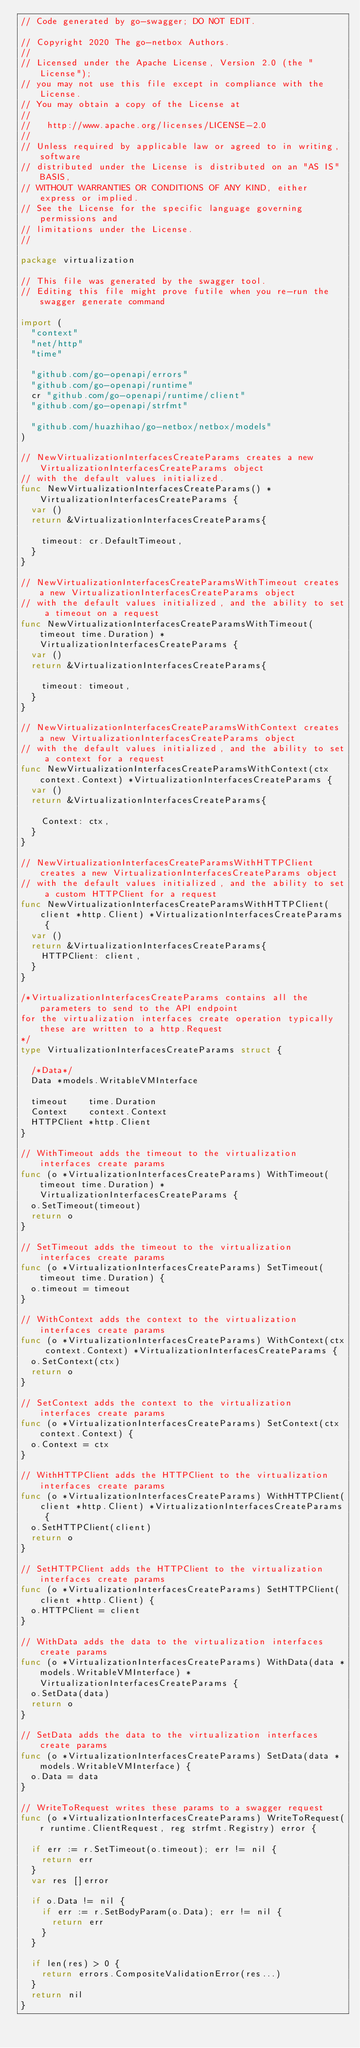Convert code to text. <code><loc_0><loc_0><loc_500><loc_500><_Go_>// Code generated by go-swagger; DO NOT EDIT.

// Copyright 2020 The go-netbox Authors.
//
// Licensed under the Apache License, Version 2.0 (the "License");
// you may not use this file except in compliance with the License.
// You may obtain a copy of the License at
//
//   http://www.apache.org/licenses/LICENSE-2.0
//
// Unless required by applicable law or agreed to in writing, software
// distributed under the License is distributed on an "AS IS" BASIS,
// WITHOUT WARRANTIES OR CONDITIONS OF ANY KIND, either express or implied.
// See the License for the specific language governing permissions and
// limitations under the License.
//

package virtualization

// This file was generated by the swagger tool.
// Editing this file might prove futile when you re-run the swagger generate command

import (
	"context"
	"net/http"
	"time"

	"github.com/go-openapi/errors"
	"github.com/go-openapi/runtime"
	cr "github.com/go-openapi/runtime/client"
	"github.com/go-openapi/strfmt"

	"github.com/huazhihao/go-netbox/netbox/models"
)

// NewVirtualizationInterfacesCreateParams creates a new VirtualizationInterfacesCreateParams object
// with the default values initialized.
func NewVirtualizationInterfacesCreateParams() *VirtualizationInterfacesCreateParams {
	var ()
	return &VirtualizationInterfacesCreateParams{

		timeout: cr.DefaultTimeout,
	}
}

// NewVirtualizationInterfacesCreateParamsWithTimeout creates a new VirtualizationInterfacesCreateParams object
// with the default values initialized, and the ability to set a timeout on a request
func NewVirtualizationInterfacesCreateParamsWithTimeout(timeout time.Duration) *VirtualizationInterfacesCreateParams {
	var ()
	return &VirtualizationInterfacesCreateParams{

		timeout: timeout,
	}
}

// NewVirtualizationInterfacesCreateParamsWithContext creates a new VirtualizationInterfacesCreateParams object
// with the default values initialized, and the ability to set a context for a request
func NewVirtualizationInterfacesCreateParamsWithContext(ctx context.Context) *VirtualizationInterfacesCreateParams {
	var ()
	return &VirtualizationInterfacesCreateParams{

		Context: ctx,
	}
}

// NewVirtualizationInterfacesCreateParamsWithHTTPClient creates a new VirtualizationInterfacesCreateParams object
// with the default values initialized, and the ability to set a custom HTTPClient for a request
func NewVirtualizationInterfacesCreateParamsWithHTTPClient(client *http.Client) *VirtualizationInterfacesCreateParams {
	var ()
	return &VirtualizationInterfacesCreateParams{
		HTTPClient: client,
	}
}

/*VirtualizationInterfacesCreateParams contains all the parameters to send to the API endpoint
for the virtualization interfaces create operation typically these are written to a http.Request
*/
type VirtualizationInterfacesCreateParams struct {

	/*Data*/
	Data *models.WritableVMInterface

	timeout    time.Duration
	Context    context.Context
	HTTPClient *http.Client
}

// WithTimeout adds the timeout to the virtualization interfaces create params
func (o *VirtualizationInterfacesCreateParams) WithTimeout(timeout time.Duration) *VirtualizationInterfacesCreateParams {
	o.SetTimeout(timeout)
	return o
}

// SetTimeout adds the timeout to the virtualization interfaces create params
func (o *VirtualizationInterfacesCreateParams) SetTimeout(timeout time.Duration) {
	o.timeout = timeout
}

// WithContext adds the context to the virtualization interfaces create params
func (o *VirtualizationInterfacesCreateParams) WithContext(ctx context.Context) *VirtualizationInterfacesCreateParams {
	o.SetContext(ctx)
	return o
}

// SetContext adds the context to the virtualization interfaces create params
func (o *VirtualizationInterfacesCreateParams) SetContext(ctx context.Context) {
	o.Context = ctx
}

// WithHTTPClient adds the HTTPClient to the virtualization interfaces create params
func (o *VirtualizationInterfacesCreateParams) WithHTTPClient(client *http.Client) *VirtualizationInterfacesCreateParams {
	o.SetHTTPClient(client)
	return o
}

// SetHTTPClient adds the HTTPClient to the virtualization interfaces create params
func (o *VirtualizationInterfacesCreateParams) SetHTTPClient(client *http.Client) {
	o.HTTPClient = client
}

// WithData adds the data to the virtualization interfaces create params
func (o *VirtualizationInterfacesCreateParams) WithData(data *models.WritableVMInterface) *VirtualizationInterfacesCreateParams {
	o.SetData(data)
	return o
}

// SetData adds the data to the virtualization interfaces create params
func (o *VirtualizationInterfacesCreateParams) SetData(data *models.WritableVMInterface) {
	o.Data = data
}

// WriteToRequest writes these params to a swagger request
func (o *VirtualizationInterfacesCreateParams) WriteToRequest(r runtime.ClientRequest, reg strfmt.Registry) error {

	if err := r.SetTimeout(o.timeout); err != nil {
		return err
	}
	var res []error

	if o.Data != nil {
		if err := r.SetBodyParam(o.Data); err != nil {
			return err
		}
	}

	if len(res) > 0 {
		return errors.CompositeValidationError(res...)
	}
	return nil
}
</code> 